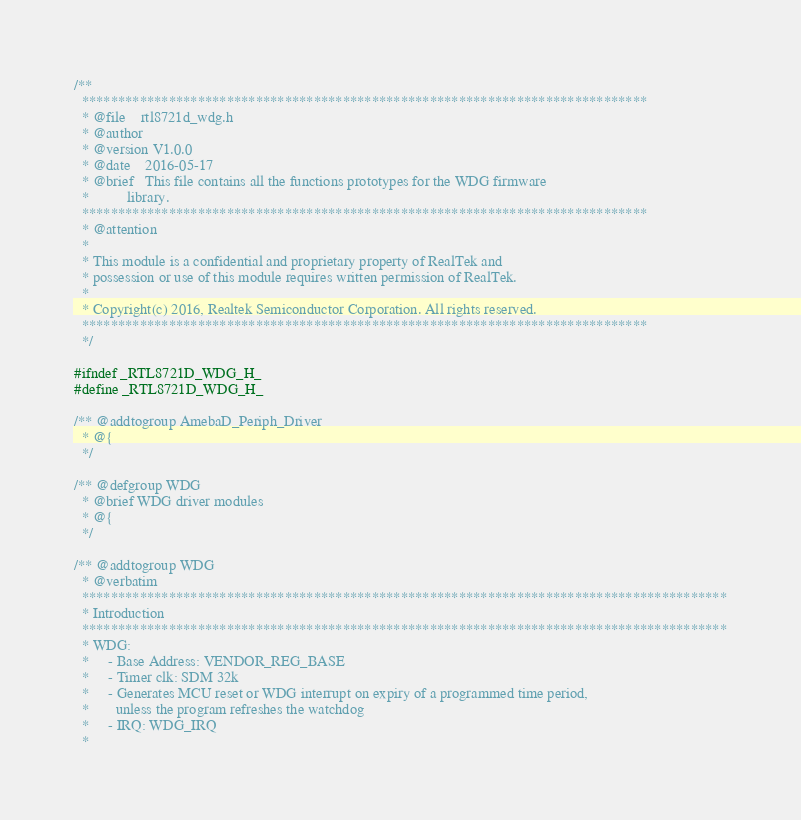Convert code to text. <code><loc_0><loc_0><loc_500><loc_500><_C_>/**
  ******************************************************************************
  * @file    rtl8721d_wdg.h
  * @author
  * @version V1.0.0
  * @date    2016-05-17
  * @brief   This file contains all the functions prototypes for the WDG firmware
  *          library.
  ******************************************************************************
  * @attention
  *
  * This module is a confidential and proprietary property of RealTek and
  * possession or use of this module requires written permission of RealTek.
  *
  * Copyright(c) 2016, Realtek Semiconductor Corporation. All rights reserved.
  ****************************************************************************** 
  */

#ifndef _RTL8721D_WDG_H_
#define _RTL8721D_WDG_H_

/** @addtogroup AmebaD_Periph_Driver
  * @{
  */

/** @defgroup WDG 
  * @brief WDG driver modules
  * @{
  */

/** @addtogroup WDG
  * @verbatim
  *****************************************************************************************
  * Introduction
  *****************************************************************************************
  * WDG:
  * 	- Base Address: VENDOR_REG_BASE
  * 	- Timer clk: SDM 32k
  * 	- Generates MCU reset or WDG interrupt on expiry of a programmed time period,
  * 	  unless the program refreshes the watchdog
  * 	- IRQ: WDG_IRQ
  *</code> 